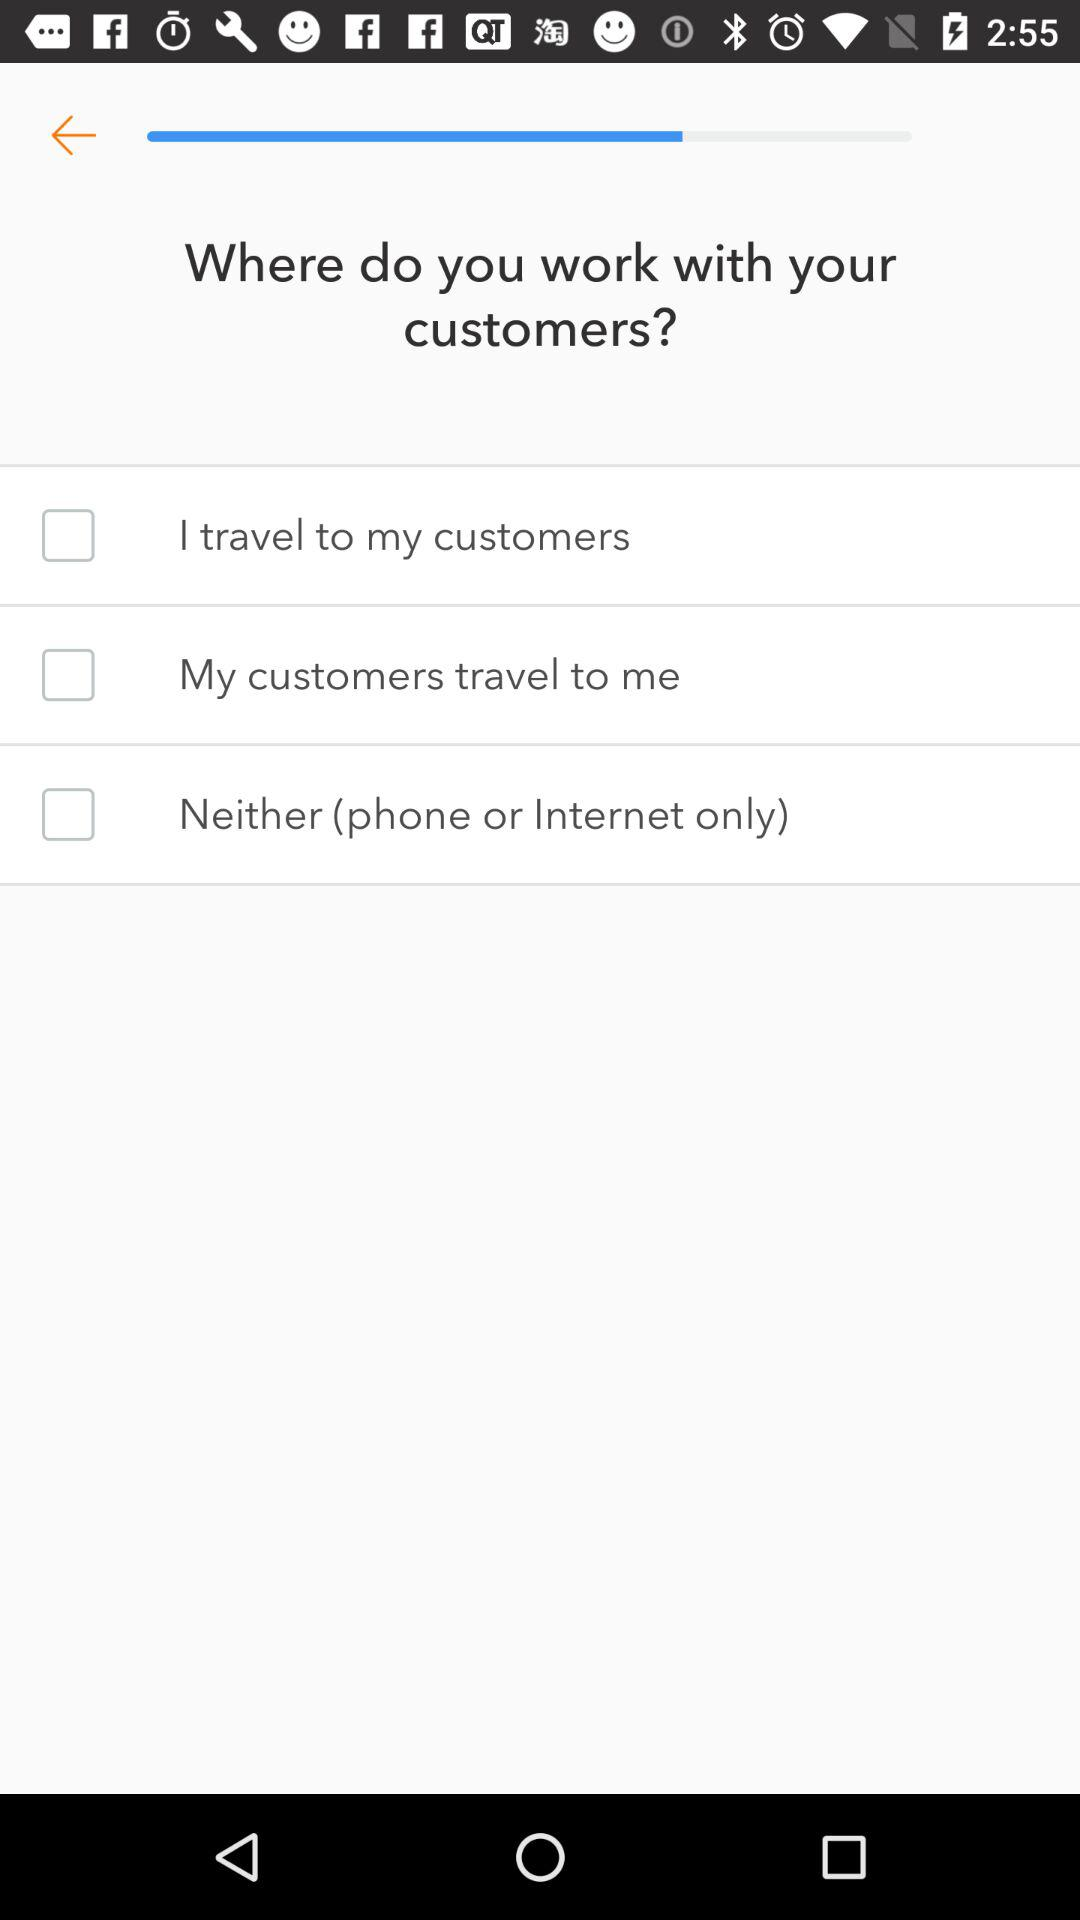How many options are there for working with customers?
Answer the question using a single word or phrase. 3 